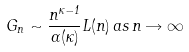Convert formula to latex. <formula><loc_0><loc_0><loc_500><loc_500>G _ { n } \sim \frac { n ^ { \kappa - 1 } } { \Gamma ( \kappa ) } L ( n ) \, a s \, n \rightarrow \infty</formula> 